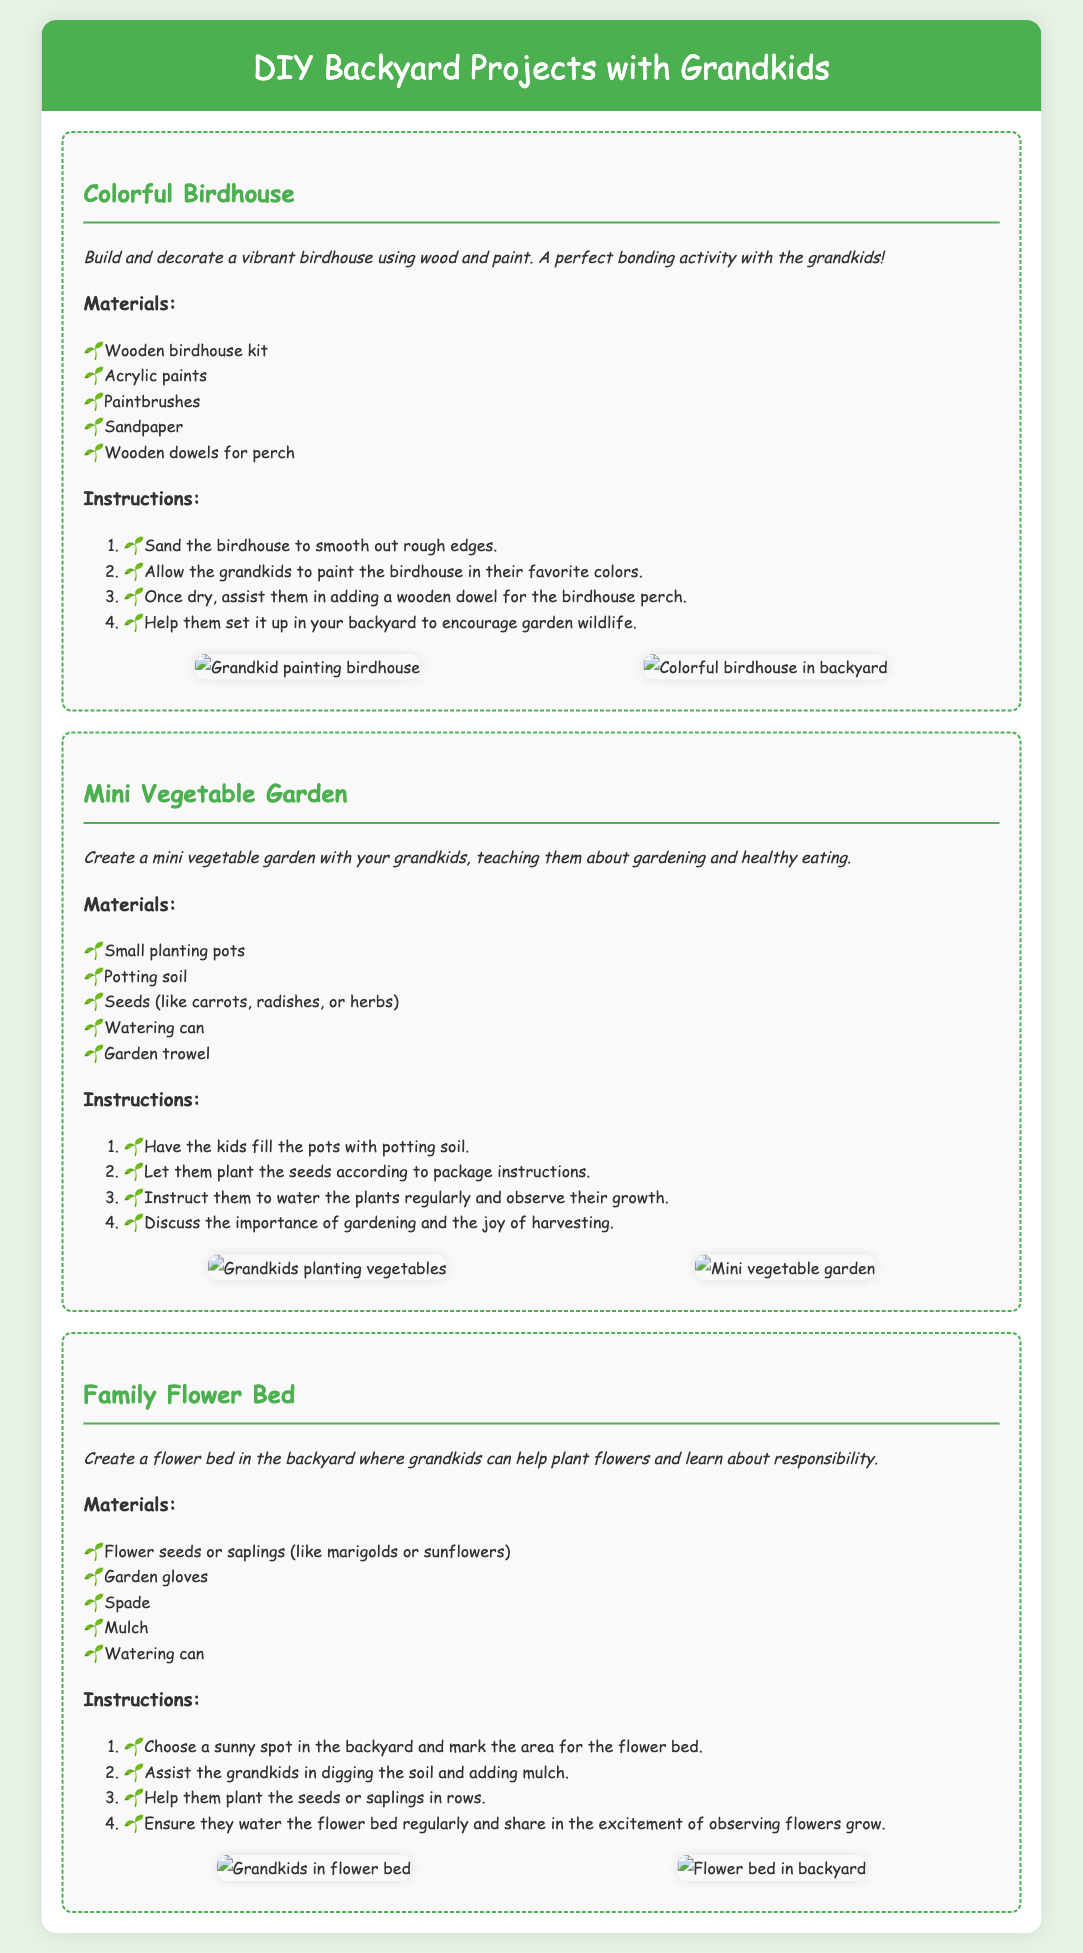What is the name of the first project? The first project is titled "Colorful Birdhouse."
Answer: Colorful Birdhouse What materials are needed for the Mini Vegetable Garden? The materials required for the Mini Vegetable Garden include small planting pots, potting soil, seeds, watering can, and garden trowel.
Answer: Small planting pots, potting soil, seeds, watering can, garden trowel How many main projects are listed in the document? The document lists three main DIY projects related to backyard activities.
Answer: Three What is the main theme of the document? The document focuses on DIY backyard projects that involve grandkids, enhancing family bonding through activities in the garden.
Answer: DIY backyard projects with grandkids What activities do the grandkids do in the Colorful Birdhouse project? The grandkids engage in activities like painting the birdhouse and adding a wooden dowel for the perch.
Answer: Painting and adding a perch Which project teaches about healthy eating? The project that teaches about healthy eating is the Mini Vegetable Garden.
Answer: Mini Vegetable Garden What type of flowers are suggested for the Family Flower Bed? Marigolds and sunflowers are suggested for the Family Flower Bed.
Answer: Marigolds, sunflowers How are the instructions organized in the document? The instructions for each project are organized in a numbered list format, facilitating step-by-step understanding.
Answer: Numbered list format 